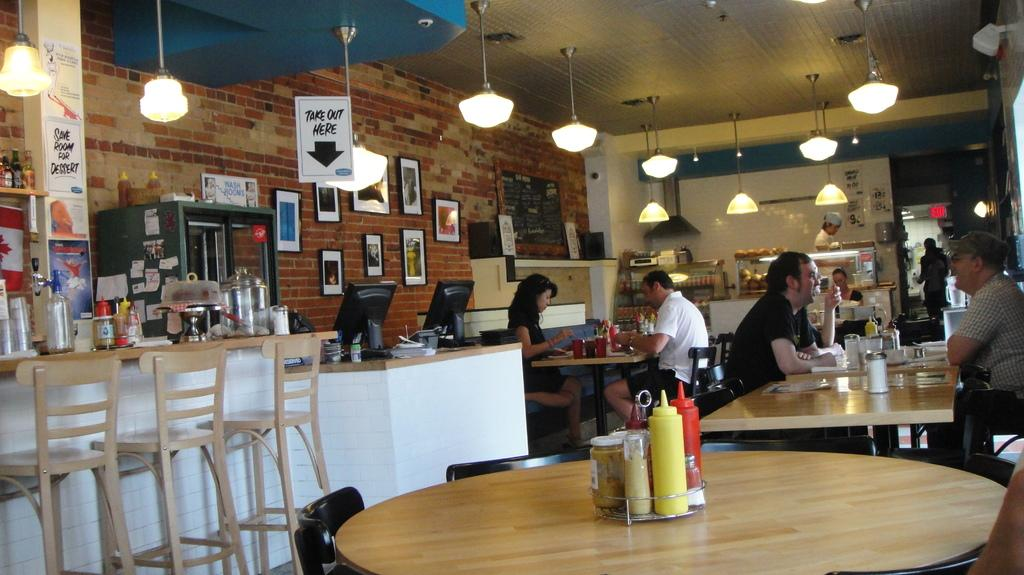What are the people in the image doing? The people in the image are sitting on chairs. How many tables can be seen in the image? There are multiple tables in the image. Are there enough chairs for everyone in the image? Yes, there are additional chairs in the image. What can be found on the walls in the image? There are frames on the wall in the image. Can you describe the design of the tiger's fur in the image? There is no tiger present in the image, so it is not possible to describe the design of its fur. 